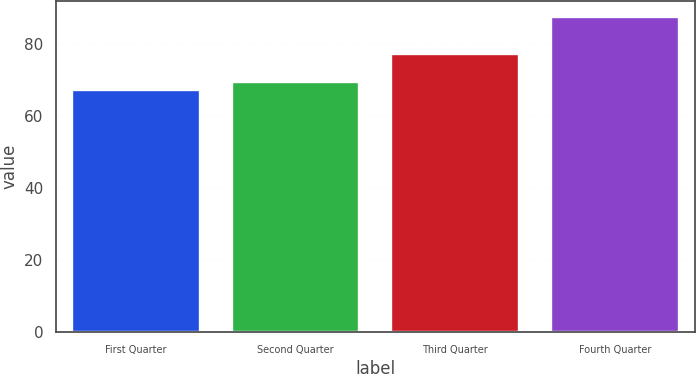Convert chart to OTSL. <chart><loc_0><loc_0><loc_500><loc_500><bar_chart><fcel>First Quarter<fcel>Second Quarter<fcel>Third Quarter<fcel>Fourth Quarter<nl><fcel>67.34<fcel>69.37<fcel>77.15<fcel>87.68<nl></chart> 